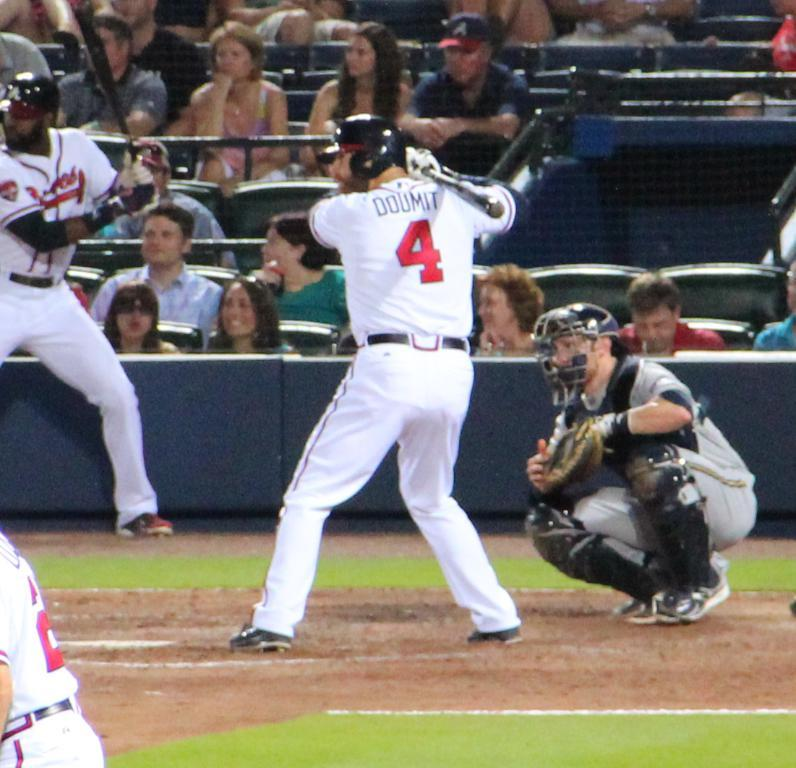<image>
Share a concise interpretation of the image provided. Player 4 named Doumit is up at bat for the Braves. 